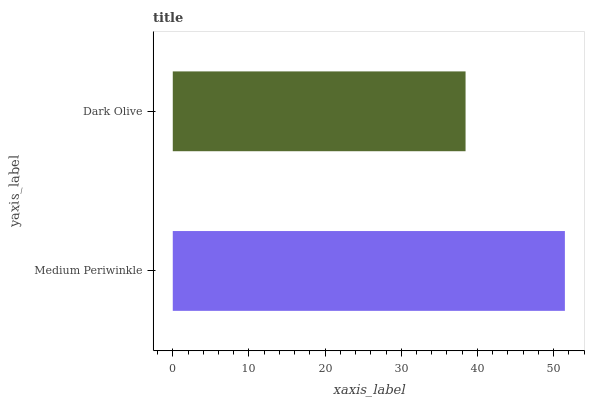Is Dark Olive the minimum?
Answer yes or no. Yes. Is Medium Periwinkle the maximum?
Answer yes or no. Yes. Is Dark Olive the maximum?
Answer yes or no. No. Is Medium Periwinkle greater than Dark Olive?
Answer yes or no. Yes. Is Dark Olive less than Medium Periwinkle?
Answer yes or no. Yes. Is Dark Olive greater than Medium Periwinkle?
Answer yes or no. No. Is Medium Periwinkle less than Dark Olive?
Answer yes or no. No. Is Medium Periwinkle the high median?
Answer yes or no. Yes. Is Dark Olive the low median?
Answer yes or no. Yes. Is Dark Olive the high median?
Answer yes or no. No. Is Medium Periwinkle the low median?
Answer yes or no. No. 